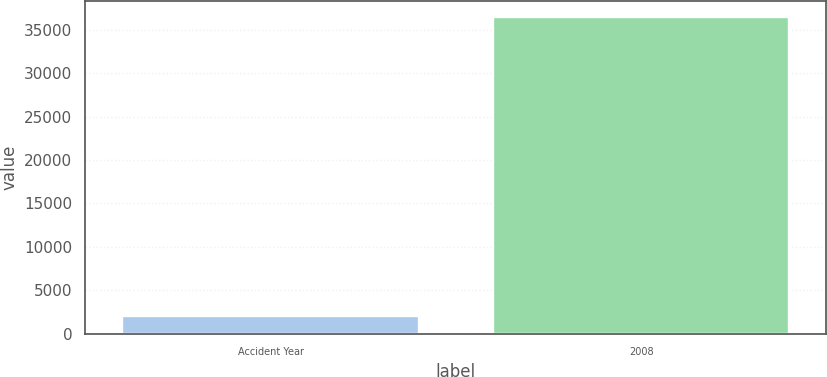<chart> <loc_0><loc_0><loc_500><loc_500><bar_chart><fcel>Accident Year<fcel>2008<nl><fcel>2016<fcel>36485<nl></chart> 